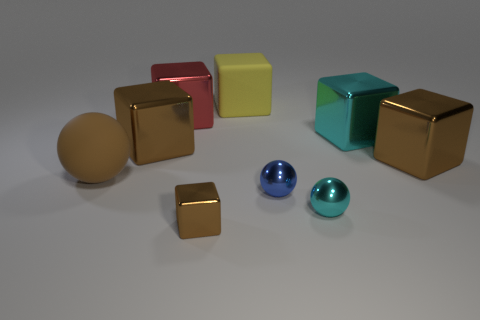Can you describe the colors of the objects? Certainly, the image showcases objects in a variety of colors. There are two golden cubes, one teal cube, one red cube, and one yellow cube. Additionally, there are two spheres, one in blue and the other in a lighter shade of teal, mirroring the color of one of the cubes. 